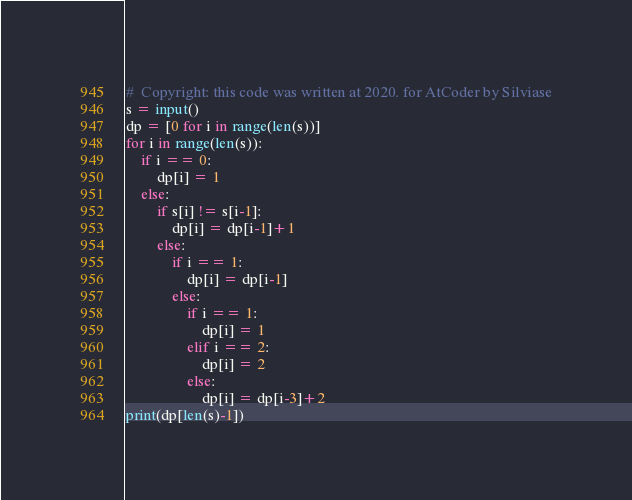<code> <loc_0><loc_0><loc_500><loc_500><_Python_>#  Copyright: this code was written at 2020. for AtCoder by Silviase
s = input()
dp = [0 for i in range(len(s))]
for i in range(len(s)):
    if i == 0:
        dp[i] = 1
    else:
        if s[i] != s[i-1]:
            dp[i] = dp[i-1]+1
        else:
            if i == 1:
                dp[i] = dp[i-1]
            else:
                if i == 1:
                    dp[i] = 1
                elif i == 2:
                    dp[i] = 2
                else:
                    dp[i] = dp[i-3]+2
print(dp[len(s)-1])
</code> 